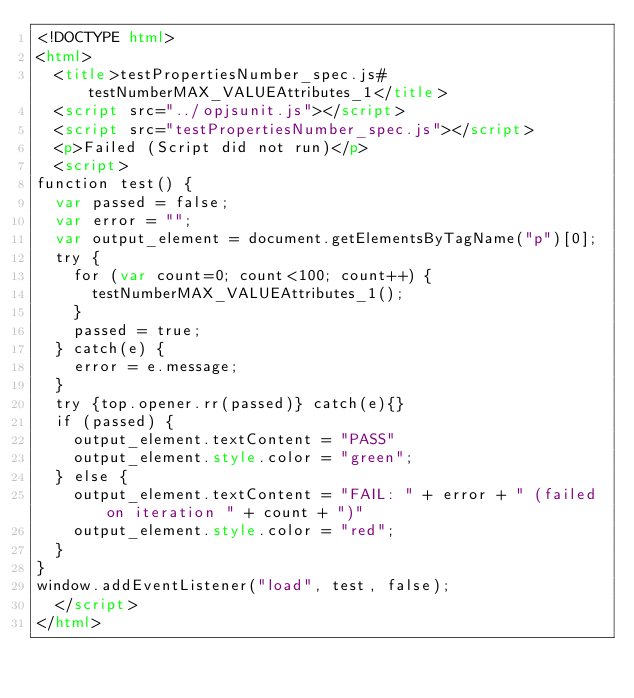Convert code to text. <code><loc_0><loc_0><loc_500><loc_500><_HTML_><!DOCTYPE html>
<html>
  <title>testPropertiesNumber_spec.js#testNumberMAX_VALUEAttributes_1</title>
  <script src="../opjsunit.js"></script>
  <script src="testPropertiesNumber_spec.js"></script>
  <p>Failed (Script did not run)</p>
  <script>
function test() {
  var passed = false;
  var error = "";
  var output_element = document.getElementsByTagName("p")[0];
  try {
    for (var count=0; count<100; count++) {
      testNumberMAX_VALUEAttributes_1();
    }
    passed = true;
  } catch(e) {
    error = e.message;
  }
  try {top.opener.rr(passed)} catch(e){}
  if (passed) {
    output_element.textContent = "PASS"
    output_element.style.color = "green";
  } else {
    output_element.textContent = "FAIL: " + error + " (failed on iteration " + count + ")"
    output_element.style.color = "red";
  }
}
window.addEventListener("load", test, false);
  </script>
</html></code> 